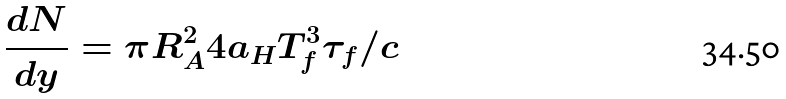<formula> <loc_0><loc_0><loc_500><loc_500>\frac { d N } { d y } = \pi R _ { A } ^ { 2 } 4 a _ { H } T _ { f } ^ { 3 } \tau _ { f } / c</formula> 